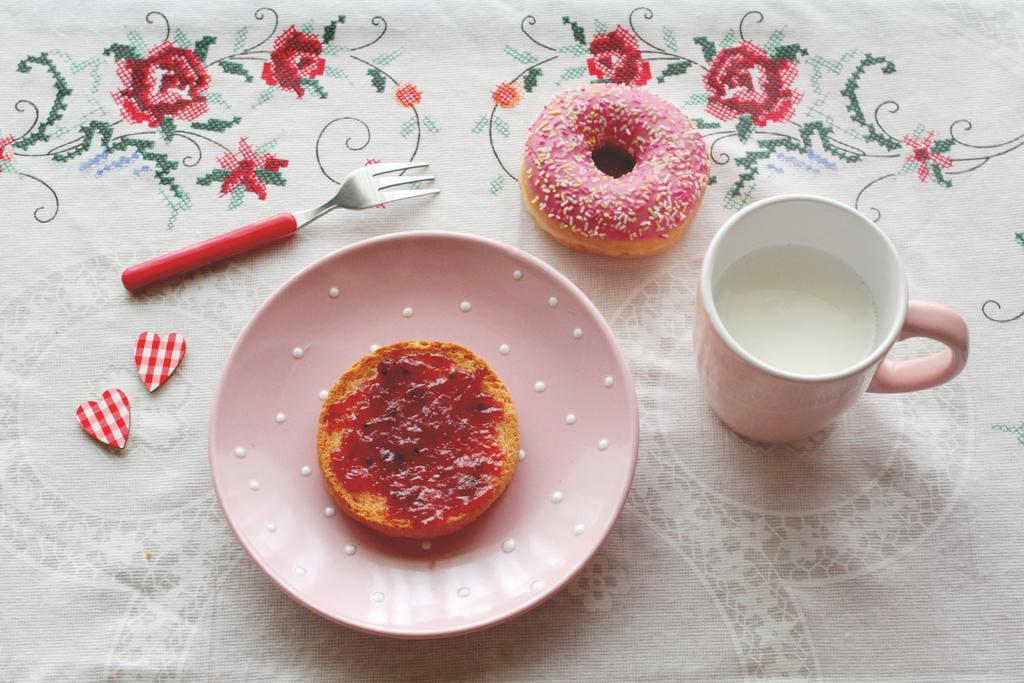What type of furniture is present in the image? The image contains a table. What is covering the table? There is a cloth on the table. What utensil can be seen on the table? There is a fork on the table. What type of food is visible on the table? There is a doughnut on the table. What is in the cup on the table? There is milk in the cup on the table. What is used to serve food on the table? There is a plate on the table. Where is the umbrella placed on the table in the image? There is no umbrella present in the image. What channel is being watched on the television in the image? There is no television present in the image. 